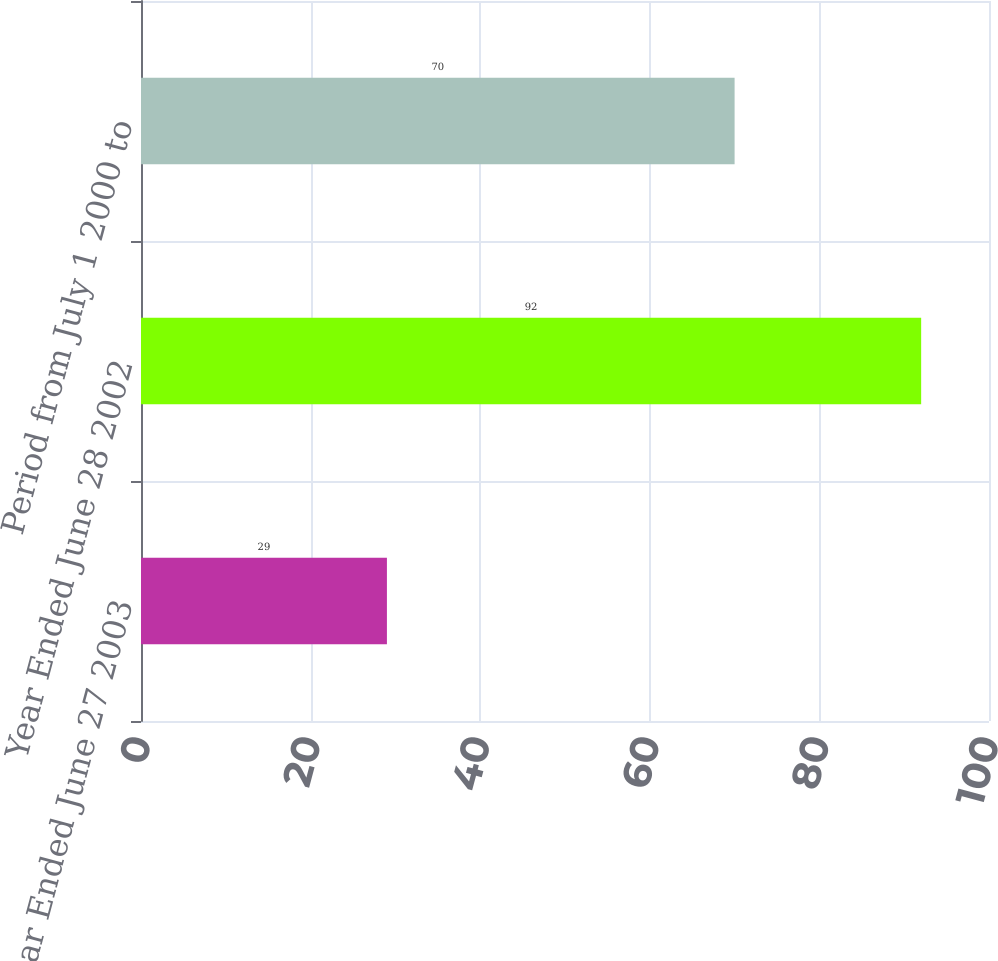<chart> <loc_0><loc_0><loc_500><loc_500><bar_chart><fcel>Year Ended June 27 2003<fcel>Year Ended June 28 2002<fcel>Period from July 1 2000 to<nl><fcel>29<fcel>92<fcel>70<nl></chart> 